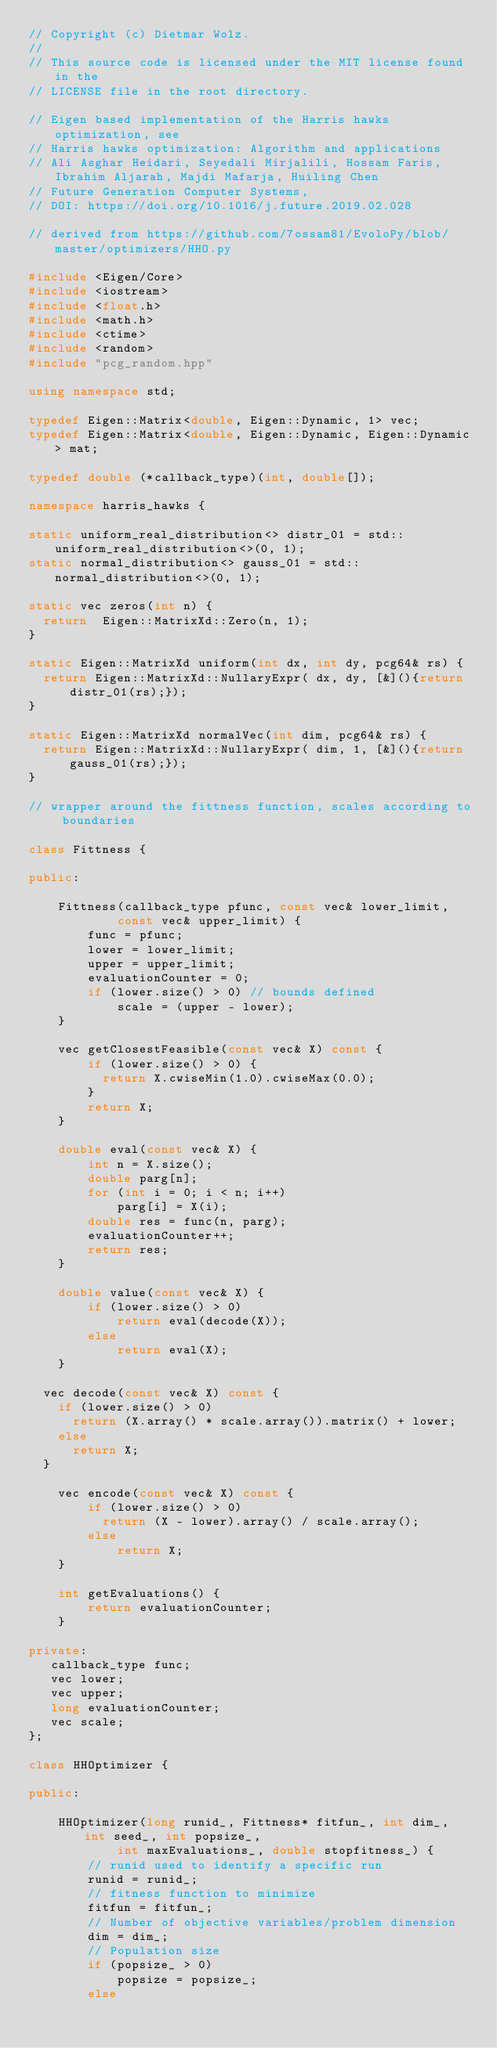<code> <loc_0><loc_0><loc_500><loc_500><_C++_>// Copyright (c) Dietmar Wolz.
//
// This source code is licensed under the MIT license found in the
// LICENSE file in the root directory.

// Eigen based implementation of the Harris hawks optimization, see
// Harris hawks optimization: Algorithm and applications
// Ali Asghar Heidari, Seyedali Mirjalili, Hossam Faris, Ibrahim Aljarah, Majdi Mafarja, Huiling Chen
// Future Generation Computer Systems, 
// DOI: https://doi.org/10.1016/j.future.2019.02.028

// derived from https://github.com/7ossam81/EvoloPy/blob/master/optimizers/HHO.py

#include <Eigen/Core>
#include <iostream>
#include <float.h>
#include <math.h>
#include <ctime>
#include <random>
#include "pcg_random.hpp"

using namespace std;

typedef Eigen::Matrix<double, Eigen::Dynamic, 1> vec;
typedef Eigen::Matrix<double, Eigen::Dynamic, Eigen::Dynamic> mat;

typedef double (*callback_type)(int, double[]);

namespace harris_hawks {

static uniform_real_distribution<> distr_01 = std::uniform_real_distribution<>(0, 1);
static normal_distribution<> gauss_01 = std::normal_distribution<>(0, 1);

static vec zeros(int n) {
	return  Eigen::MatrixXd::Zero(n, 1);
}

static Eigen::MatrixXd uniform(int dx, int dy, pcg64& rs) {
	return Eigen::MatrixXd::NullaryExpr( dx, dy, [&](){return distr_01(rs);});
}

static Eigen::MatrixXd normalVec(int dim, pcg64& rs) {
	return Eigen::MatrixXd::NullaryExpr( dim, 1, [&](){return gauss_01(rs);});
}

// wrapper around the fittness function, scales according to boundaries

class Fittness {

public:

    Fittness(callback_type pfunc, const vec& lower_limit,
            const vec& upper_limit) {
        func = pfunc;
        lower = lower_limit;
        upper = upper_limit;
        evaluationCounter = 0;
        if (lower.size() > 0) // bounds defined
            scale = (upper - lower);
    }

    vec getClosestFeasible(const vec& X) const {
        if (lower.size() > 0) {
        	return X.cwiseMin(1.0).cwiseMax(0.0);
        }
        return X;
    }

    double eval(const vec& X) {
        int n = X.size();
        double parg[n];
        for (int i = 0; i < n; i++)
            parg[i] = X(i);
        double res = func(n, parg);
        evaluationCounter++;
        return res;
    }

    double value(const vec& X) {
        if (lower.size() > 0)
            return eval(decode(X));
        else
            return eval(X);
    }

	vec decode(const vec& X) const {
		if (lower.size() > 0)
			return (X.array() * scale.array()).matrix() + lower;
		else
			return X;
	}

    vec encode(const vec& X) const {
        if (lower.size() > 0)
        	return (X - lower).array() / scale.array();
        else
            return X;
    }

    int getEvaluations() {
        return evaluationCounter;
    }

private:
   callback_type func;
   vec lower;
   vec upper;
   long evaluationCounter;
   vec scale;
};

class HHOptimizer {

public:

    HHOptimizer(long runid_, Fittness* fitfun_, int dim_, int seed_, int popsize_, 
            int maxEvaluations_, double stopfitness_) {
        // runid used to identify a specific run
        runid = runid_;
        // fitness function to minimize
        fitfun = fitfun_;
        // Number of objective variables/problem dimension
        dim = dim_;
        // Population size
        if (popsize_ > 0)
            popsize = popsize_;
        else</code> 